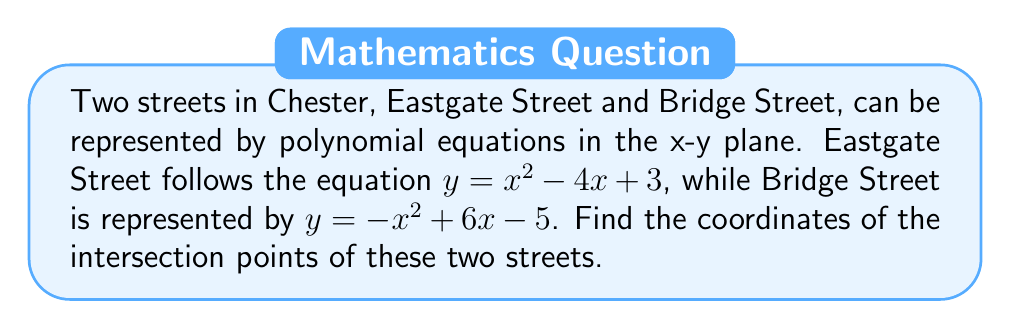Teach me how to tackle this problem. To find the intersection points, we need to solve the system of equations:

$$\begin{cases}
y = x^2 - 4x + 3 \quad \text{(Eastgate Street)} \\
y = -x^2 + 6x - 5 \quad \text{(Bridge Street)}
\end{cases}$$

1) Set the equations equal to each other:
   $x^2 - 4x + 3 = -x^2 + 6x - 5$

2) Rearrange all terms to one side:
   $2x^2 - 10x + 8 = 0$

3) Divide all terms by 2:
   $x^2 - 5x + 4 = 0$

4) This is a quadratic equation. We can solve it using the quadratic formula:
   $x = \frac{-b \pm \sqrt{b^2 - 4ac}}{2a}$, where $a=1$, $b=-5$, and $c=4$

5) Substituting these values:
   $x = \frac{5 \pm \sqrt{25 - 16}}{2} = \frac{5 \pm 3}{2}$

6) This gives us two solutions:
   $x_1 = \frac{5 + 3}{2} = 4$ and $x_2 = \frac{5 - 3}{2} = 1$

7) To find the corresponding y-coordinates, we can substitute these x-values into either of the original equations. Let's use Eastgate Street's equation:

   For $x_1 = 4$: $y = 4^2 - 4(4) + 3 = 16 - 16 + 3 = 3$
   For $x_2 = 1$: $y = 1^2 - 4(1) + 3 = 1 - 4 + 3 = 0$

Therefore, the intersection points are (4, 3) and (1, 0).
Answer: (4, 3) and (1, 0) 